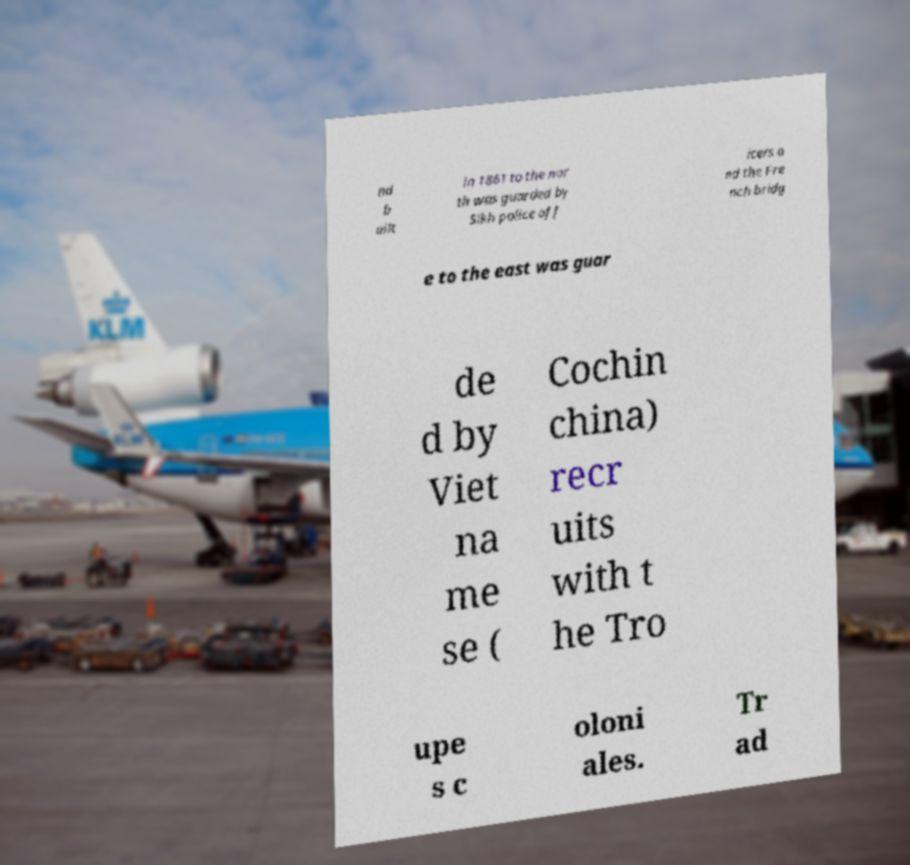I need the written content from this picture converted into text. Can you do that? nd b uilt in 1861 to the nor th was guarded by Sikh police off icers a nd the Fre nch bridg e to the east was guar de d by Viet na me se ( Cochin china) recr uits with t he Tro upe s c oloni ales. Tr ad 